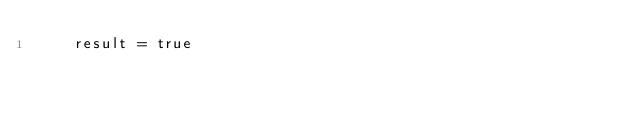Convert code to text. <code><loc_0><loc_0><loc_500><loc_500><_Nim_>    result = true
</code> 